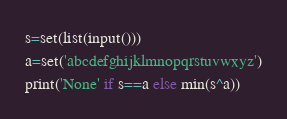Convert code to text. <code><loc_0><loc_0><loc_500><loc_500><_Python_>s=set(list(input()))
a=set('abcdefghijklmnopqrstuvwxyz')
print('None' if s==a else min(s^a))</code> 